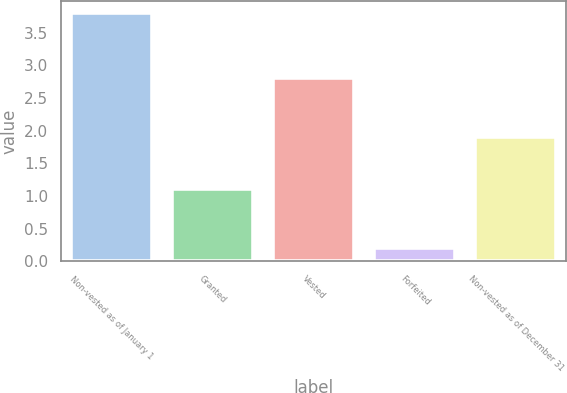Convert chart to OTSL. <chart><loc_0><loc_0><loc_500><loc_500><bar_chart><fcel>Non-vested as of January 1<fcel>Granted<fcel>Vested<fcel>Forfeited<fcel>Non-vested as of December 31<nl><fcel>3.8<fcel>1.1<fcel>2.8<fcel>0.2<fcel>1.9<nl></chart> 